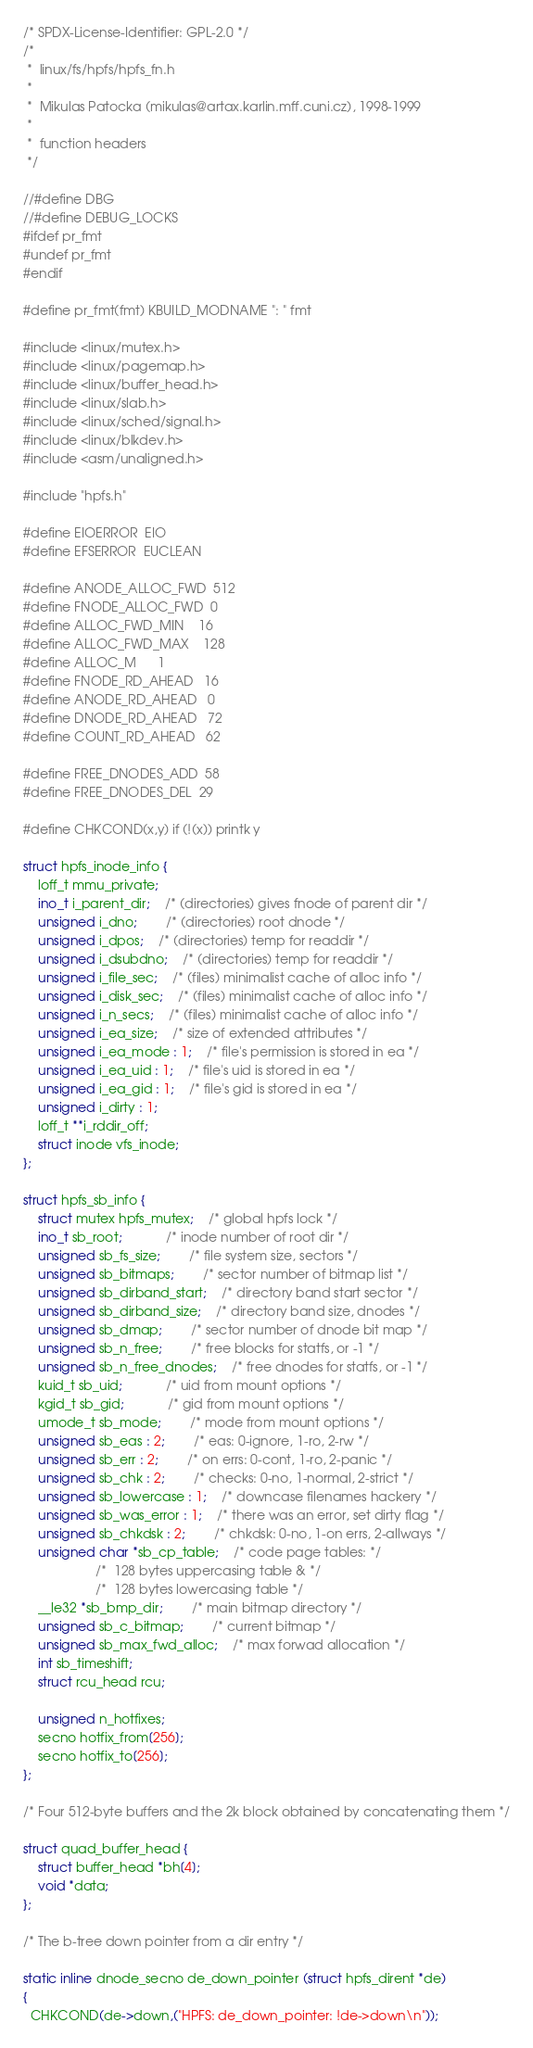<code> <loc_0><loc_0><loc_500><loc_500><_C_>/* SPDX-License-Identifier: GPL-2.0 */
/*
 *  linux/fs/hpfs/hpfs_fn.h
 *
 *  Mikulas Patocka (mikulas@artax.karlin.mff.cuni.cz), 1998-1999
 *
 *  function headers
 */

//#define DBG
//#define DEBUG_LOCKS
#ifdef pr_fmt
#undef pr_fmt
#endif

#define pr_fmt(fmt) KBUILD_MODNAME ": " fmt

#include <linux/mutex.h>
#include <linux/pagemap.h>
#include <linux/buffer_head.h>
#include <linux/slab.h>
#include <linux/sched/signal.h>
#include <linux/blkdev.h>
#include <asm/unaligned.h>

#include "hpfs.h"

#define EIOERROR  EIO
#define EFSERROR  EUCLEAN

#define ANODE_ALLOC_FWD	512
#define FNODE_ALLOC_FWD	0
#define ALLOC_FWD_MIN	16
#define ALLOC_FWD_MAX	128
#define ALLOC_M		1
#define FNODE_RD_AHEAD	16
#define ANODE_RD_AHEAD	0
#define DNODE_RD_AHEAD	72
#define COUNT_RD_AHEAD	62

#define FREE_DNODES_ADD	58
#define FREE_DNODES_DEL	29

#define CHKCOND(x,y) if (!(x)) printk y

struct hpfs_inode_info {
	loff_t mmu_private;
	ino_t i_parent_dir;	/* (directories) gives fnode of parent dir */
	unsigned i_dno;		/* (directories) root dnode */
	unsigned i_dpos;	/* (directories) temp for readdir */
	unsigned i_dsubdno;	/* (directories) temp for readdir */
	unsigned i_file_sec;	/* (files) minimalist cache of alloc info */
	unsigned i_disk_sec;	/* (files) minimalist cache of alloc info */
	unsigned i_n_secs;	/* (files) minimalist cache of alloc info */
	unsigned i_ea_size;	/* size of extended attributes */
	unsigned i_ea_mode : 1;	/* file's permission is stored in ea */
	unsigned i_ea_uid : 1;	/* file's uid is stored in ea */
	unsigned i_ea_gid : 1;	/* file's gid is stored in ea */
	unsigned i_dirty : 1;
	loff_t **i_rddir_off;
	struct inode vfs_inode;
};

struct hpfs_sb_info {
	struct mutex hpfs_mutex;	/* global hpfs lock */
	ino_t sb_root;			/* inode number of root dir */
	unsigned sb_fs_size;		/* file system size, sectors */
	unsigned sb_bitmaps;		/* sector number of bitmap list */
	unsigned sb_dirband_start;	/* directory band start sector */
	unsigned sb_dirband_size;	/* directory band size, dnodes */
	unsigned sb_dmap;		/* sector number of dnode bit map */
	unsigned sb_n_free;		/* free blocks for statfs, or -1 */
	unsigned sb_n_free_dnodes;	/* free dnodes for statfs, or -1 */
	kuid_t sb_uid;			/* uid from mount options */
	kgid_t sb_gid;			/* gid from mount options */
	umode_t sb_mode;		/* mode from mount options */
	unsigned sb_eas : 2;		/* eas: 0-ignore, 1-ro, 2-rw */
	unsigned sb_err : 2;		/* on errs: 0-cont, 1-ro, 2-panic */
	unsigned sb_chk : 2;		/* checks: 0-no, 1-normal, 2-strict */
	unsigned sb_lowercase : 1;	/* downcase filenames hackery */
	unsigned sb_was_error : 1;	/* there was an error, set dirty flag */
	unsigned sb_chkdsk : 2;		/* chkdsk: 0-no, 1-on errs, 2-allways */
	unsigned char *sb_cp_table;	/* code page tables: */
					/* 	128 bytes uppercasing table & */
					/*	128 bytes lowercasing table */
	__le32 *sb_bmp_dir;		/* main bitmap directory */
	unsigned sb_c_bitmap;		/* current bitmap */
	unsigned sb_max_fwd_alloc;	/* max forwad allocation */
	int sb_timeshift;
	struct rcu_head rcu;

	unsigned n_hotfixes;
	secno hotfix_from[256];
	secno hotfix_to[256];
};

/* Four 512-byte buffers and the 2k block obtained by concatenating them */

struct quad_buffer_head {
	struct buffer_head *bh[4];
	void *data;
};

/* The b-tree down pointer from a dir entry */

static inline dnode_secno de_down_pointer (struct hpfs_dirent *de)
{
  CHKCOND(de->down,("HPFS: de_down_pointer: !de->down\n"));</code> 